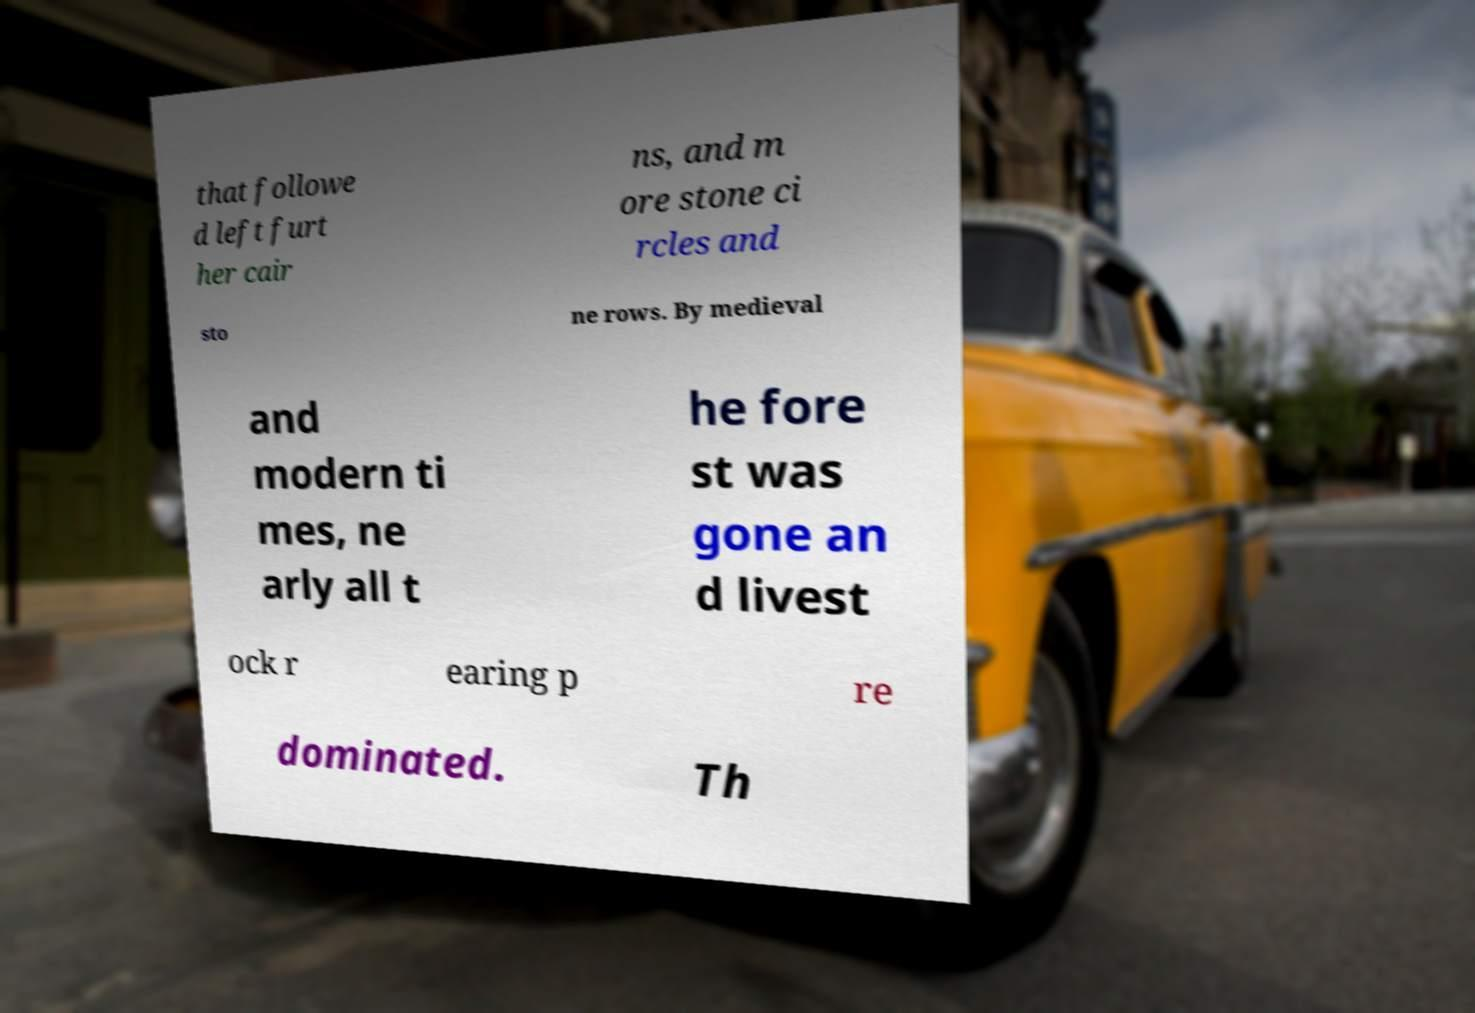Could you assist in decoding the text presented in this image and type it out clearly? that followe d left furt her cair ns, and m ore stone ci rcles and sto ne rows. By medieval and modern ti mes, ne arly all t he fore st was gone an d livest ock r earing p re dominated. Th 